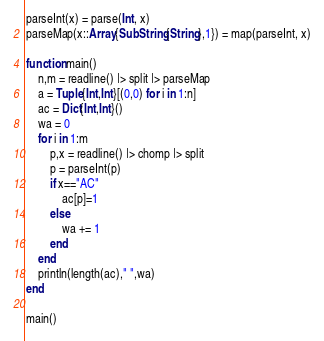<code> <loc_0><loc_0><loc_500><loc_500><_Julia_>parseInt(x) = parse(Int, x)
parseMap(x::Array{SubString{String},1}) = map(parseInt, x)

function main()
	n,m = readline() |> split |> parseMap
	a = Tuple{Int,Int}[(0,0) for i in 1:n]
	ac = Dict{Int,Int}()
	wa = 0
	for i in 1:m
		p,x = readline() |> chomp |> split
		p = parseInt(p)
		if x=="AC"
			ac[p]=1
		else
			wa += 1
		end
	end
	println(length(ac)," ",wa)
end

main()</code> 